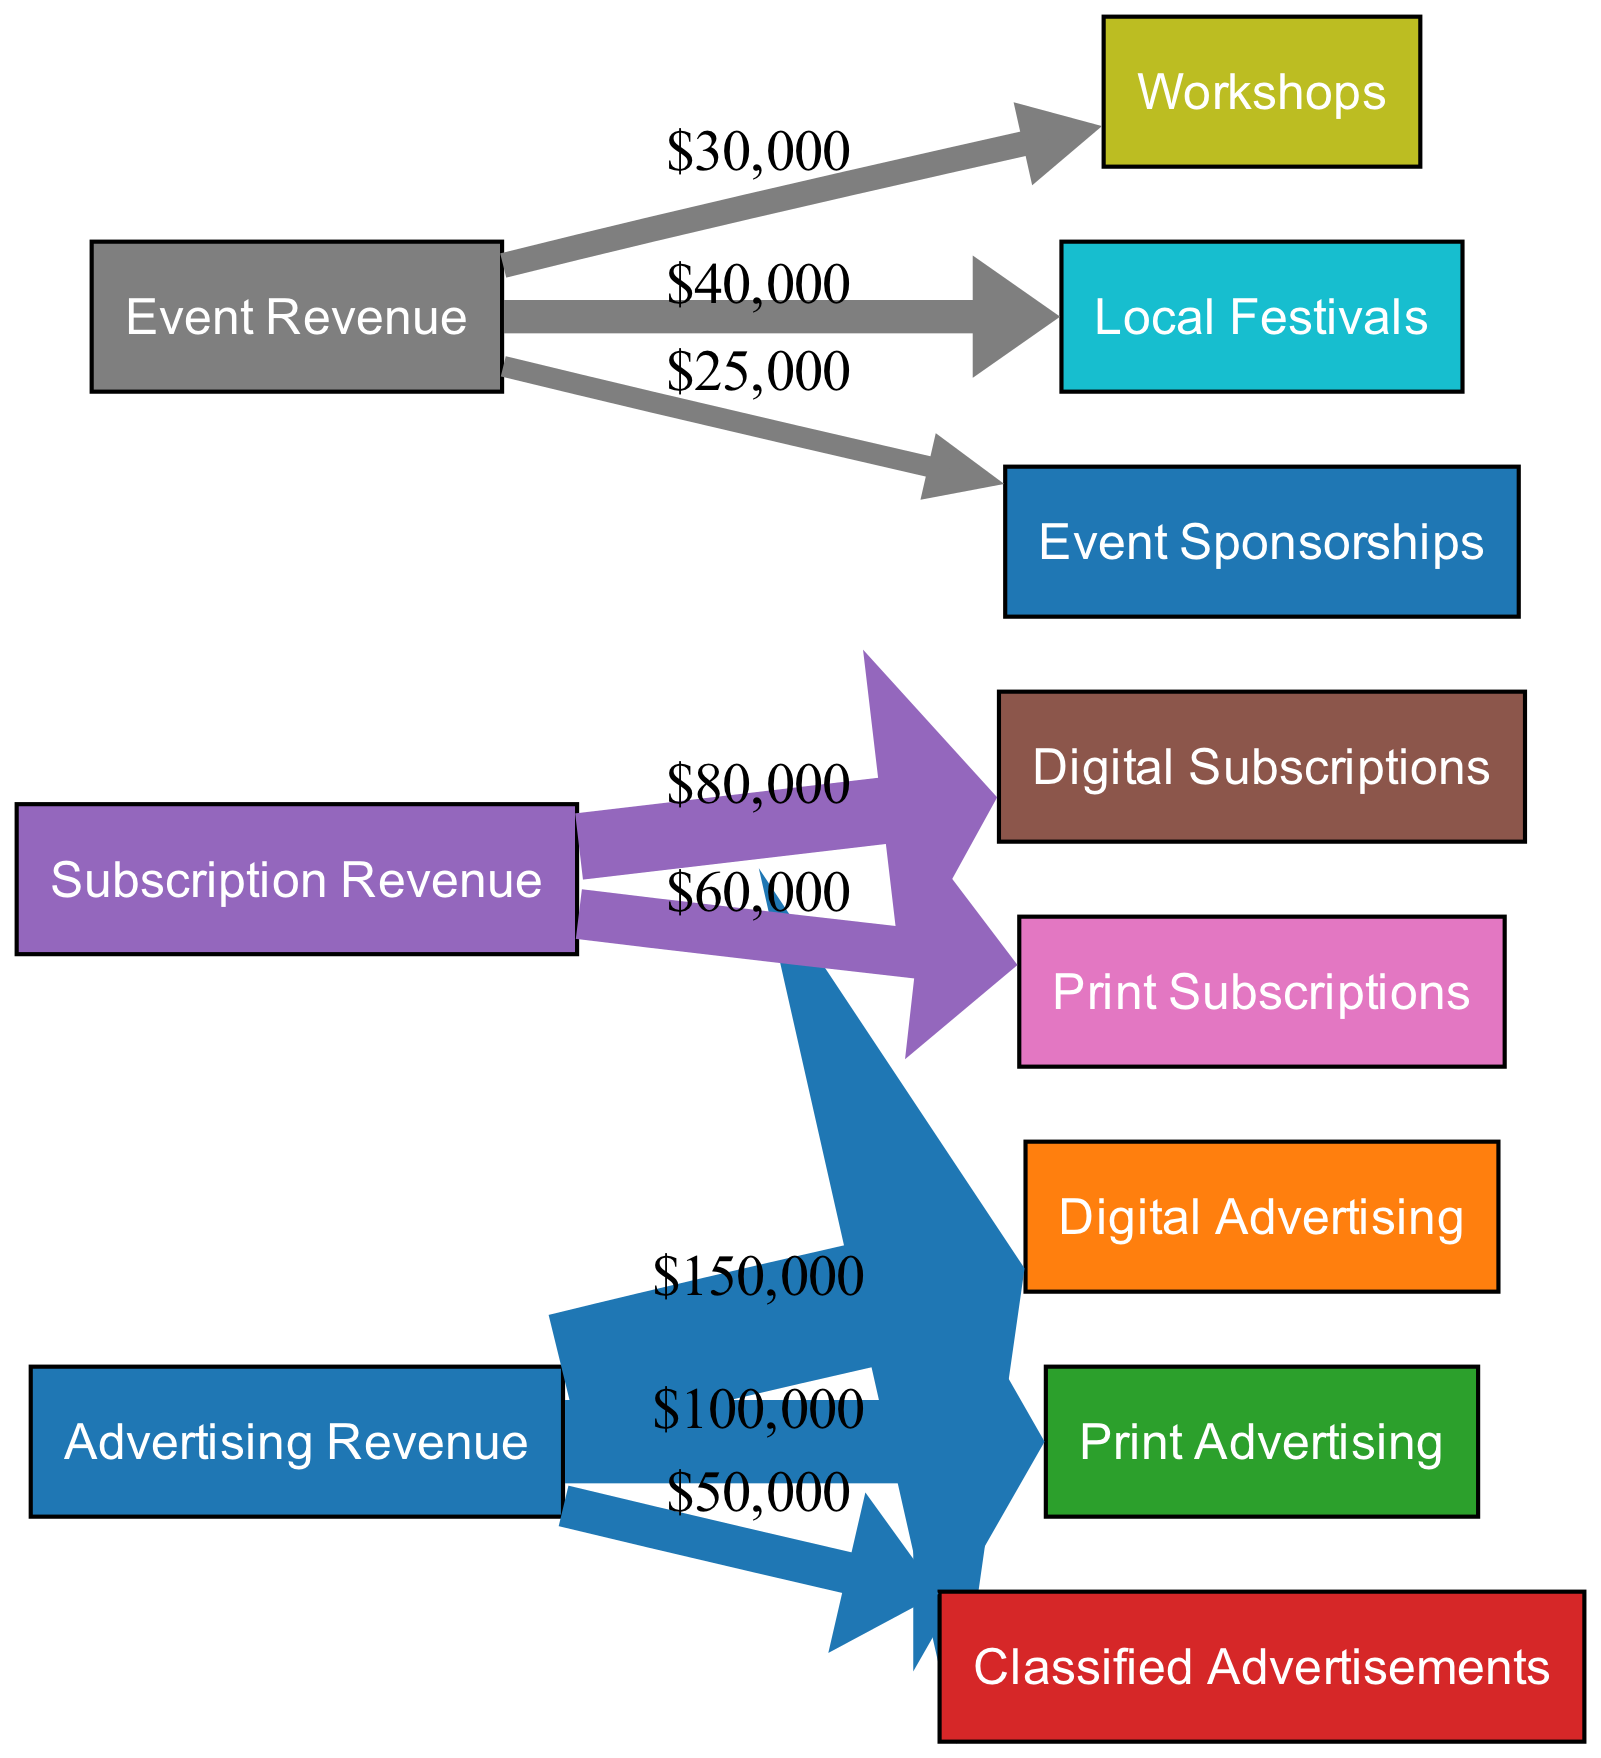What is the total revenue from advertising? To find the total revenue from advertising, we add the values of all the links originating from the "Advertising" node: $150,000 (Digital Ads) + $100,000 (Print Ads) + $50,000 (Classifieds) = $300,000.
Answer: $300,000 How much revenue comes from print subscriptions? The revenue from print subscriptions is directly obtained from the link connecting "Subscriptions" to "Print Subscriptions," which shows a value of $60,000.
Answer: $60,000 What is the value of local festivals revenue? The revenue from local festivals is indicated by the link between "Events" and "Local Festivals," with a value of $40,000.
Answer: $40,000 What is the total revenue from events? To calculate the total revenue from events, we sum the values of all links from the "Events" node: $30,000 (Workshops) + $40,000 (Local Festivals) + $25,000 (Sponsorships) = $95,000.
Answer: $95,000 Which type of advertising generates the most revenue? The digital advertising revenue is the highest among the different types of advertising, with a value of $150,000, compared to $100,000 for print ads and $50,000 for classifieds.
Answer: Digital Advertising What is the total number of nodes in the diagram? The diagram includes 11 nodes, which are identified as sources and targets of the revenue flows.
Answer: 11 What is the ratio of digital advertising revenue to print advertising revenue? To find the ratio, we take the digital advertising revenue of $150,000 and compare it to the print advertising revenue of $100,000. The ratio simplifies to 3:2.
Answer: 3:2 How many types of events are recorded in the revenue flow? There are three types of events represented in the diagram: Workshops, Local Festivals, and Sponsorships, each contributing to the event revenue.
Answer: 3 Which node has the least revenue flow? The node with the least revenue flow is classified advertisements, with a value of $50,000, which is the smallest among the revenues listed.
Answer: Classified Advertisements 